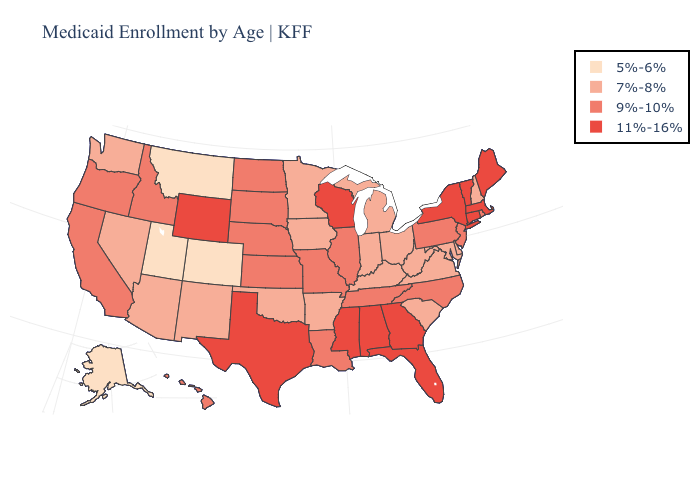What is the highest value in the MidWest ?
Give a very brief answer. 11%-16%. Does the first symbol in the legend represent the smallest category?
Concise answer only. Yes. Does Illinois have the lowest value in the USA?
Short answer required. No. Name the states that have a value in the range 5%-6%?
Answer briefly. Alaska, Colorado, Montana, Utah. What is the highest value in the USA?
Answer briefly. 11%-16%. Which states have the highest value in the USA?
Write a very short answer. Alabama, Connecticut, Florida, Georgia, Maine, Massachusetts, Mississippi, New York, Texas, Vermont, Wisconsin, Wyoming. Which states have the highest value in the USA?
Concise answer only. Alabama, Connecticut, Florida, Georgia, Maine, Massachusetts, Mississippi, New York, Texas, Vermont, Wisconsin, Wyoming. Which states have the lowest value in the USA?
Answer briefly. Alaska, Colorado, Montana, Utah. Among the states that border Colorado , does Wyoming have the highest value?
Concise answer only. Yes. What is the value of West Virginia?
Be succinct. 7%-8%. What is the value of Connecticut?
Be succinct. 11%-16%. Name the states that have a value in the range 5%-6%?
Quick response, please. Alaska, Colorado, Montana, Utah. Does Missouri have a lower value than Alaska?
Concise answer only. No. Name the states that have a value in the range 11%-16%?
Quick response, please. Alabama, Connecticut, Florida, Georgia, Maine, Massachusetts, Mississippi, New York, Texas, Vermont, Wisconsin, Wyoming. 